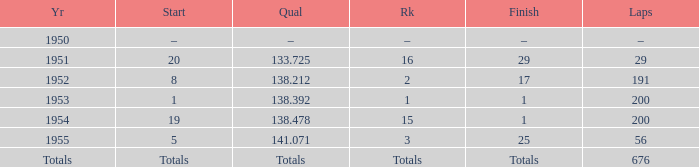What ranking that had a start of 19? 15.0. 